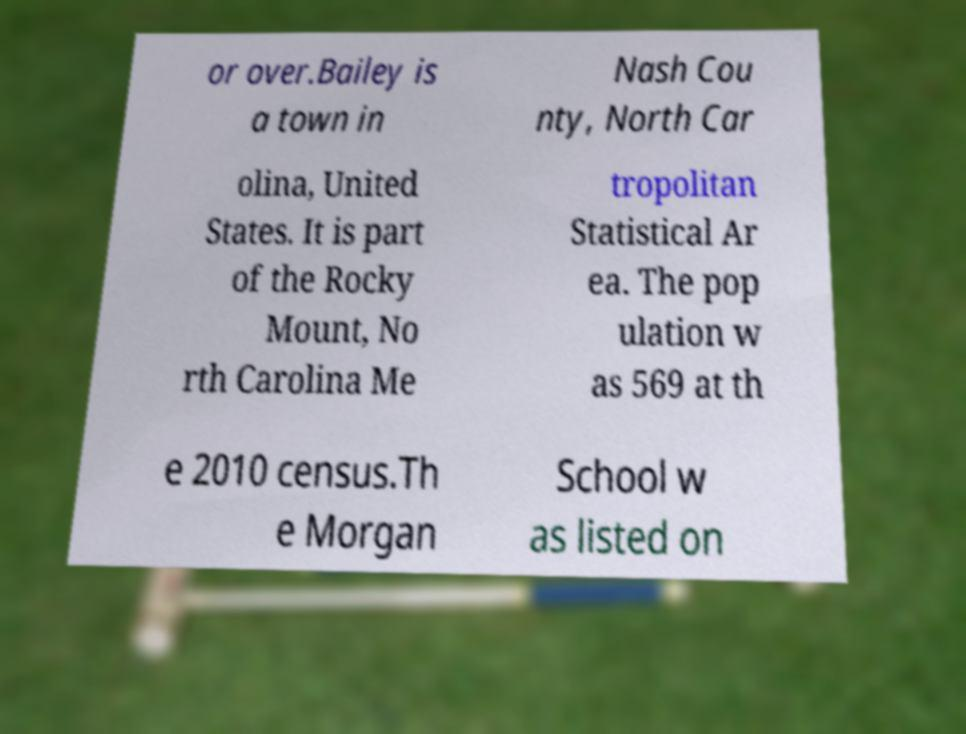Can you read and provide the text displayed in the image?This photo seems to have some interesting text. Can you extract and type it out for me? or over.Bailey is a town in Nash Cou nty, North Car olina, United States. It is part of the Rocky Mount, No rth Carolina Me tropolitan Statistical Ar ea. The pop ulation w as 569 at th e 2010 census.Th e Morgan School w as listed on 